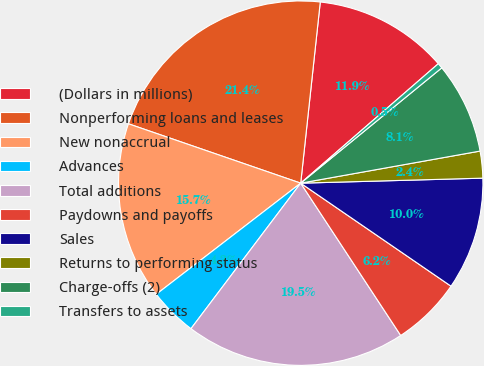<chart> <loc_0><loc_0><loc_500><loc_500><pie_chart><fcel>(Dollars in millions)<fcel>Nonperforming loans and leases<fcel>New nonaccrual<fcel>Advances<fcel>Total additions<fcel>Paydowns and payoffs<fcel>Sales<fcel>Returns to performing status<fcel>Charge-offs (2)<fcel>Transfers to assets<nl><fcel>11.91%<fcel>21.43%<fcel>15.72%<fcel>4.28%<fcel>19.53%<fcel>6.19%<fcel>10.0%<fcel>2.38%<fcel>8.09%<fcel>0.47%<nl></chart> 